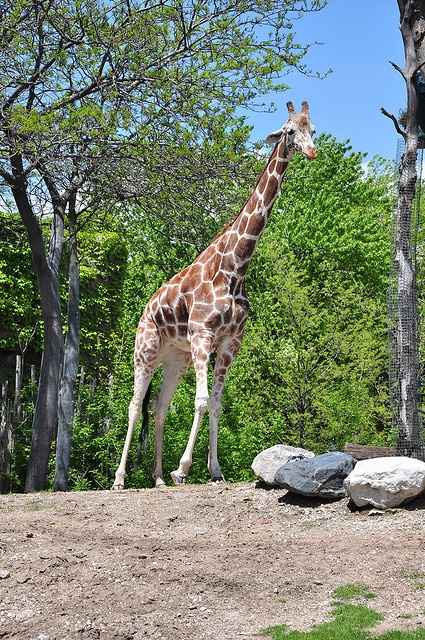Describe the objects in this image and their specific colors. I can see a giraffe in gray, white, and darkgray tones in this image. 